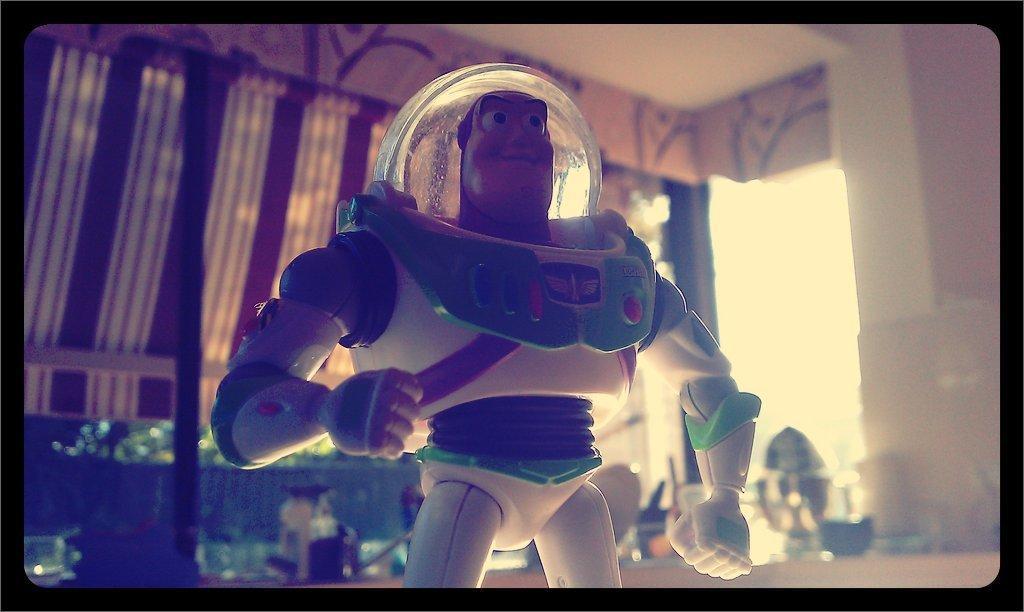Could you give a brief overview of what you see in this image? In this image we can see a toy. In the background there are objects, cloth and wall. 